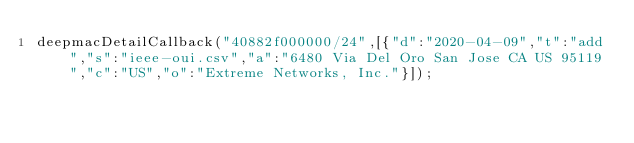<code> <loc_0><loc_0><loc_500><loc_500><_JavaScript_>deepmacDetailCallback("40882f000000/24",[{"d":"2020-04-09","t":"add","s":"ieee-oui.csv","a":"6480 Via Del Oro San Jose CA US 95119","c":"US","o":"Extreme Networks, Inc."}]);
</code> 